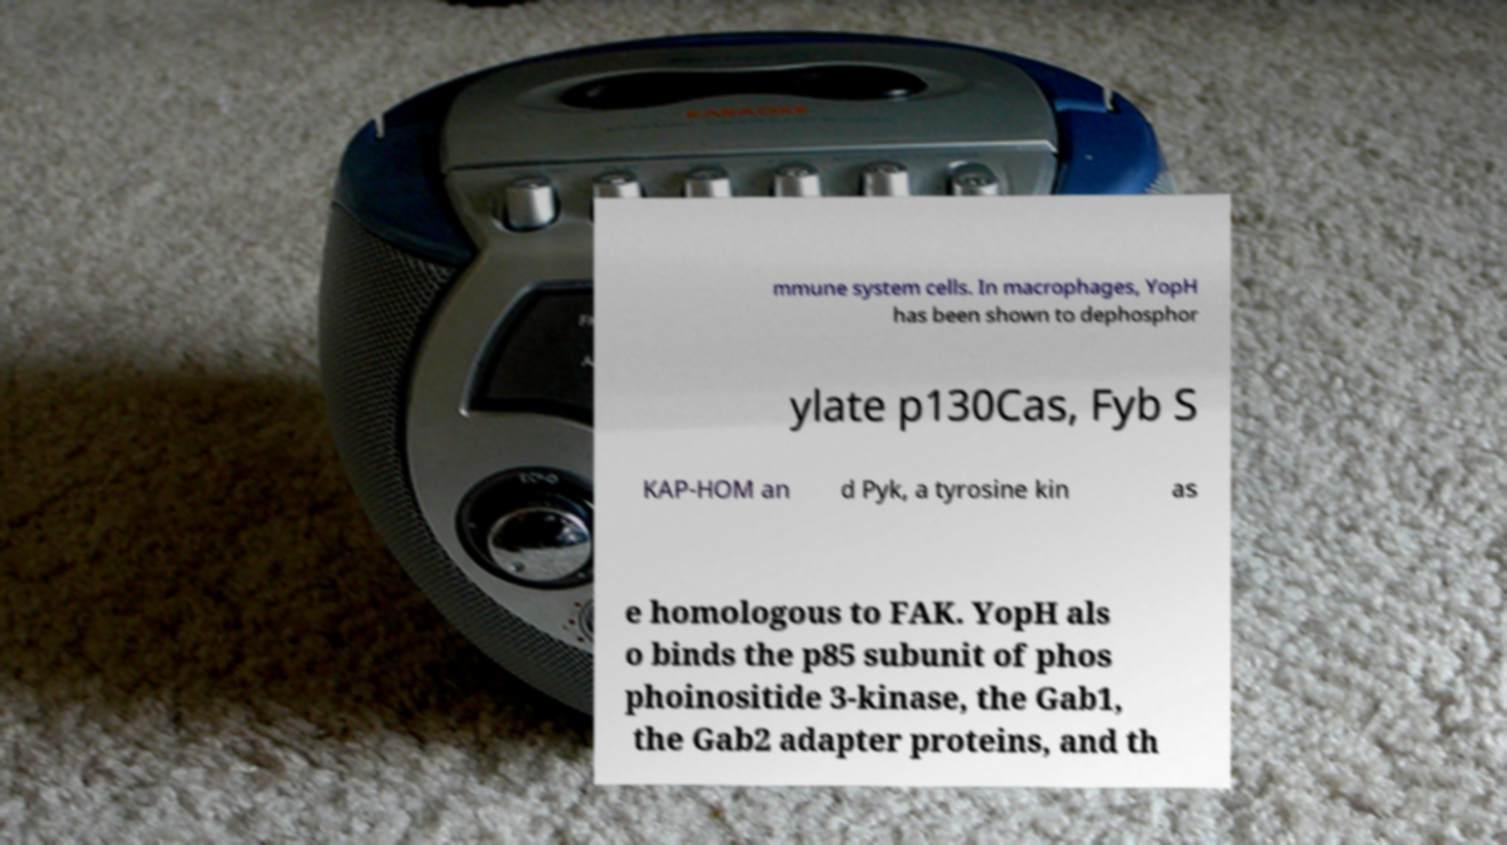Please read and relay the text visible in this image. What does it say? mmune system cells. In macrophages, YopH has been shown to dephosphor ylate p130Cas, Fyb S KAP-HOM an d Pyk, a tyrosine kin as e homologous to FAK. YopH als o binds the p85 subunit of phos phoinositide 3-kinase, the Gab1, the Gab2 adapter proteins, and th 